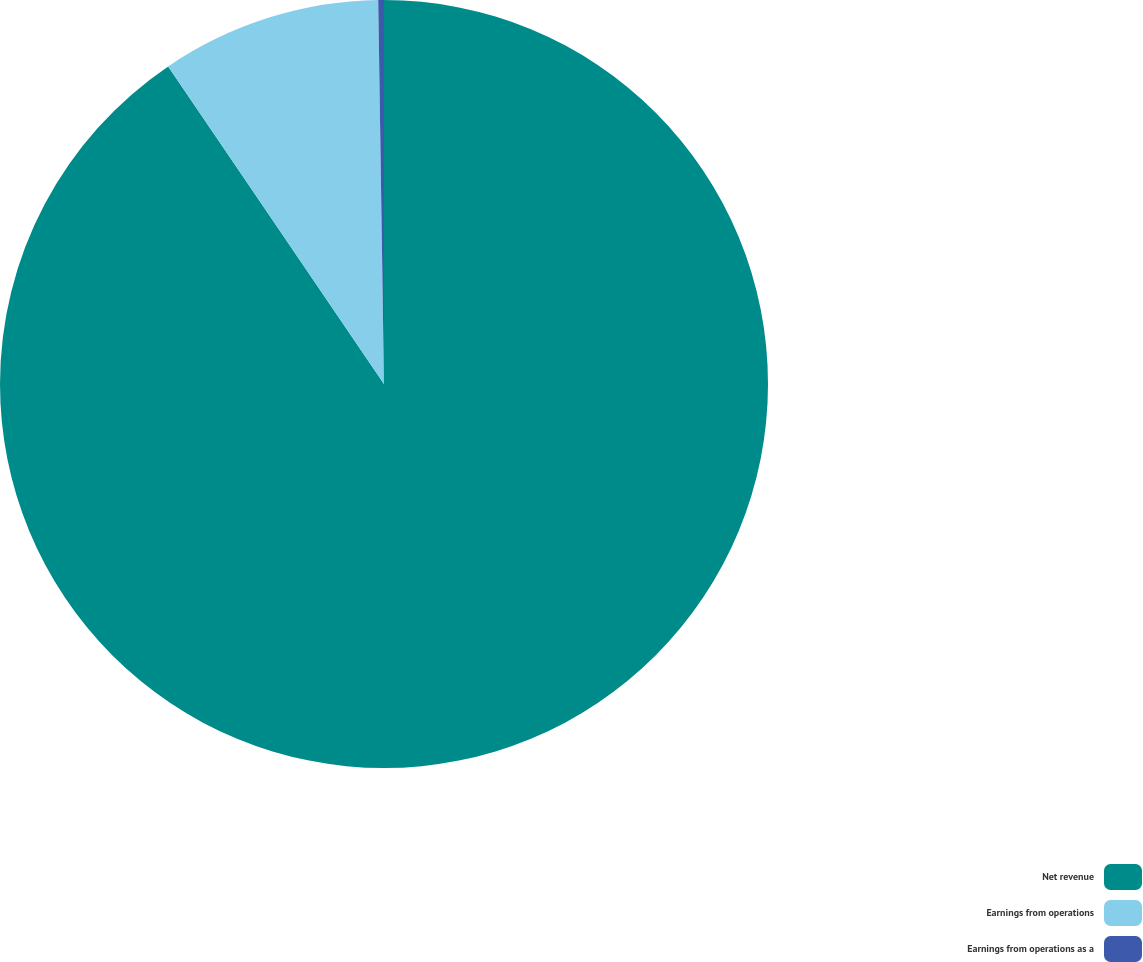Convert chart to OTSL. <chart><loc_0><loc_0><loc_500><loc_500><pie_chart><fcel>Net revenue<fcel>Earnings from operations<fcel>Earnings from operations as a<nl><fcel>90.5%<fcel>9.26%<fcel>0.24%<nl></chart> 